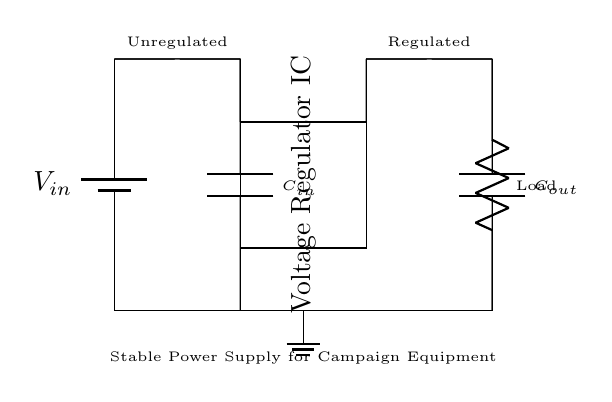What type of voltage regulator is used in this circuit? The circuit uses a linear voltage regulator, which maintains a constant output voltage despite variations in input voltage or load conditions. The rectangular shape labeled "Voltage Regulator IC" indicates that a specific chip is used to achieve this stabilization.
Answer: Linear voltage regulator What is the function of the capacitors in this circuit? The input capacitor, labeled as C-in, filters the input voltage by smoothing out fluctuations and protects the regulator from sudden changes. The output capacitor, labeled as C-out, stabilizes the output voltage and reduces voltage ripple, ensuring a smooth power supply to the load.
Answer: Filtering and stabilization What is the role of the load in the circuit? The load, represented as a resistor, consumes the regulated output voltage provided by the voltage regulator. It represents the devices and equipment in the campaign office that require stable power for operation.
Answer: Consumes power What happens if the input voltage fluctuates significantly? If the input voltage varies significantly, the voltage regulator will adjust its output to keep it stable according to its design specifications, typically within a certain range, thereby protecting the load from voltage disturbances.
Answer: Output remains stable What is the voltage before regulation indicated in the diagram? The voltage before regulation is labeled as V-in. The circuit diagram does not provide a specific numerical value for V-in, but it implies the incoming voltage is unregulated.
Answer: Unregulated voltage How do the capacitors affect the performance of the regulator? Capacitors impact the performance by ensuring consistent voltage levels: the input capacitor helps in dealing with sudden voltage drops while the output capacitor ensures that the voltage output remains steady, thereby enhancing the overall performance of the regulator circuit under varying loads.
Answer: Enhance stability and performance 